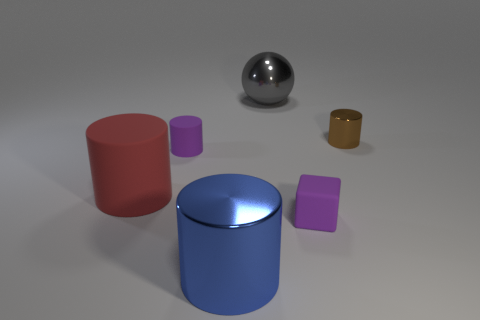Subtract all large rubber cylinders. How many cylinders are left? 3 Add 1 tiny brown metallic things. How many objects exist? 7 Subtract all brown cylinders. How many cylinders are left? 3 Subtract all cyan cylinders. Subtract all yellow cubes. How many cylinders are left? 4 Subtract all spheres. How many objects are left? 5 Add 5 purple cylinders. How many purple cylinders are left? 6 Add 4 small metallic cylinders. How many small metallic cylinders exist? 5 Subtract 0 red balls. How many objects are left? 6 Subtract all large cyan blocks. Subtract all large objects. How many objects are left? 3 